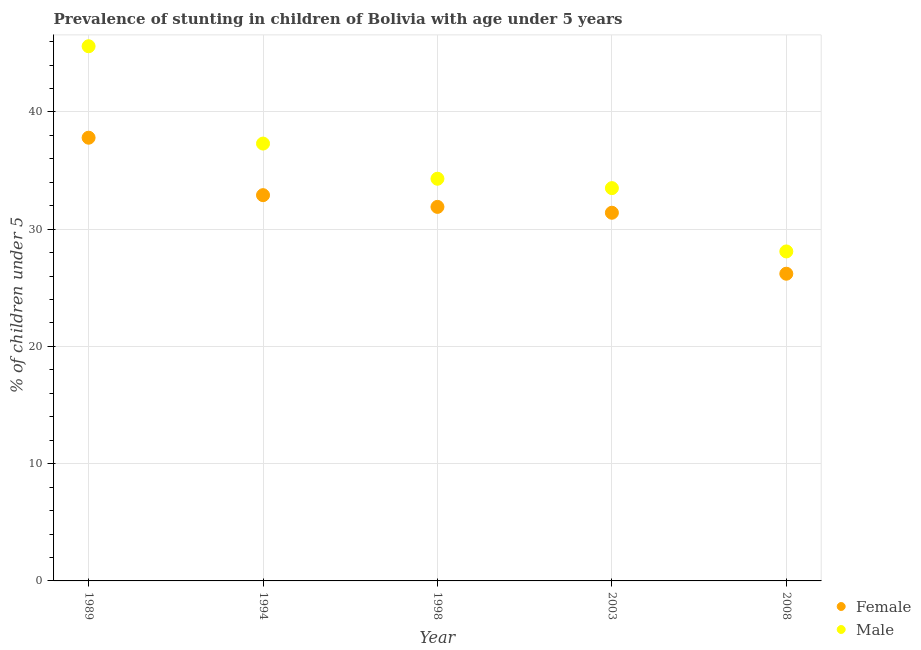What is the percentage of stunted male children in 1998?
Your response must be concise. 34.3. Across all years, what is the maximum percentage of stunted female children?
Provide a short and direct response. 37.8. Across all years, what is the minimum percentage of stunted female children?
Your answer should be very brief. 26.2. In which year was the percentage of stunted male children minimum?
Offer a terse response. 2008. What is the total percentage of stunted female children in the graph?
Provide a succinct answer. 160.2. What is the difference between the percentage of stunted male children in 1989 and that in 1998?
Ensure brevity in your answer.  11.3. What is the difference between the percentage of stunted male children in 1998 and the percentage of stunted female children in 2008?
Offer a terse response. 8.1. What is the average percentage of stunted female children per year?
Your response must be concise. 32.04. In the year 1998, what is the difference between the percentage of stunted male children and percentage of stunted female children?
Offer a very short reply. 2.4. What is the ratio of the percentage of stunted male children in 1994 to that in 2008?
Your response must be concise. 1.33. What is the difference between the highest and the second highest percentage of stunted male children?
Your response must be concise. 8.3. What is the difference between the highest and the lowest percentage of stunted female children?
Offer a very short reply. 11.6. In how many years, is the percentage of stunted male children greater than the average percentage of stunted male children taken over all years?
Provide a short and direct response. 2. Does the percentage of stunted female children monotonically increase over the years?
Your response must be concise. No. Is the percentage of stunted female children strictly greater than the percentage of stunted male children over the years?
Your response must be concise. No. Is the percentage of stunted male children strictly less than the percentage of stunted female children over the years?
Your answer should be very brief. No. What is the title of the graph?
Give a very brief answer. Prevalence of stunting in children of Bolivia with age under 5 years. What is the label or title of the X-axis?
Give a very brief answer. Year. What is the label or title of the Y-axis?
Ensure brevity in your answer.   % of children under 5. What is the  % of children under 5 in Female in 1989?
Keep it short and to the point. 37.8. What is the  % of children under 5 in Male in 1989?
Your answer should be very brief. 45.6. What is the  % of children under 5 in Female in 1994?
Give a very brief answer. 32.9. What is the  % of children under 5 in Male in 1994?
Your answer should be compact. 37.3. What is the  % of children under 5 of Female in 1998?
Your answer should be very brief. 31.9. What is the  % of children under 5 of Male in 1998?
Provide a short and direct response. 34.3. What is the  % of children under 5 in Female in 2003?
Provide a short and direct response. 31.4. What is the  % of children under 5 of Male in 2003?
Keep it short and to the point. 33.5. What is the  % of children under 5 of Female in 2008?
Give a very brief answer. 26.2. What is the  % of children under 5 in Male in 2008?
Your answer should be very brief. 28.1. Across all years, what is the maximum  % of children under 5 of Female?
Your response must be concise. 37.8. Across all years, what is the maximum  % of children under 5 in Male?
Ensure brevity in your answer.  45.6. Across all years, what is the minimum  % of children under 5 of Female?
Give a very brief answer. 26.2. Across all years, what is the minimum  % of children under 5 of Male?
Provide a short and direct response. 28.1. What is the total  % of children under 5 of Female in the graph?
Ensure brevity in your answer.  160.2. What is the total  % of children under 5 of Male in the graph?
Give a very brief answer. 178.8. What is the difference between the  % of children under 5 in Male in 1989 and that in 1994?
Offer a terse response. 8.3. What is the difference between the  % of children under 5 of Male in 1989 and that in 1998?
Offer a very short reply. 11.3. What is the difference between the  % of children under 5 of Female in 1989 and that in 2003?
Ensure brevity in your answer.  6.4. What is the difference between the  % of children under 5 in Male in 1989 and that in 2003?
Offer a terse response. 12.1. What is the difference between the  % of children under 5 of Female in 1989 and that in 2008?
Keep it short and to the point. 11.6. What is the difference between the  % of children under 5 of Female in 1994 and that in 1998?
Provide a succinct answer. 1. What is the difference between the  % of children under 5 of Male in 1994 and that in 2003?
Your response must be concise. 3.8. What is the difference between the  % of children under 5 of Female in 1994 and that in 2008?
Make the answer very short. 6.7. What is the difference between the  % of children under 5 of Female in 1998 and that in 2003?
Your response must be concise. 0.5. What is the difference between the  % of children under 5 in Male in 1998 and that in 2003?
Your response must be concise. 0.8. What is the difference between the  % of children under 5 of Male in 1998 and that in 2008?
Your answer should be compact. 6.2. What is the difference between the  % of children under 5 of Female in 2003 and that in 2008?
Make the answer very short. 5.2. What is the difference between the  % of children under 5 in Male in 2003 and that in 2008?
Provide a short and direct response. 5.4. What is the difference between the  % of children under 5 of Female in 1989 and the  % of children under 5 of Male in 1994?
Offer a terse response. 0.5. What is the difference between the  % of children under 5 in Female in 1989 and the  % of children under 5 in Male in 2003?
Keep it short and to the point. 4.3. What is the difference between the  % of children under 5 in Female in 1994 and the  % of children under 5 in Male in 2008?
Your response must be concise. 4.8. What is the difference between the  % of children under 5 in Female in 2003 and the  % of children under 5 in Male in 2008?
Provide a short and direct response. 3.3. What is the average  % of children under 5 in Female per year?
Your response must be concise. 32.04. What is the average  % of children under 5 of Male per year?
Provide a succinct answer. 35.76. In the year 1989, what is the difference between the  % of children under 5 of Female and  % of children under 5 of Male?
Provide a short and direct response. -7.8. In the year 1994, what is the difference between the  % of children under 5 in Female and  % of children under 5 in Male?
Offer a very short reply. -4.4. In the year 1998, what is the difference between the  % of children under 5 in Female and  % of children under 5 in Male?
Give a very brief answer. -2.4. What is the ratio of the  % of children under 5 of Female in 1989 to that in 1994?
Give a very brief answer. 1.15. What is the ratio of the  % of children under 5 in Male in 1989 to that in 1994?
Provide a succinct answer. 1.22. What is the ratio of the  % of children under 5 of Female in 1989 to that in 1998?
Provide a succinct answer. 1.19. What is the ratio of the  % of children under 5 in Male in 1989 to that in 1998?
Ensure brevity in your answer.  1.33. What is the ratio of the  % of children under 5 in Female in 1989 to that in 2003?
Your answer should be very brief. 1.2. What is the ratio of the  % of children under 5 in Male in 1989 to that in 2003?
Offer a terse response. 1.36. What is the ratio of the  % of children under 5 in Female in 1989 to that in 2008?
Give a very brief answer. 1.44. What is the ratio of the  % of children under 5 of Male in 1989 to that in 2008?
Your response must be concise. 1.62. What is the ratio of the  % of children under 5 in Female in 1994 to that in 1998?
Offer a very short reply. 1.03. What is the ratio of the  % of children under 5 of Male in 1994 to that in 1998?
Keep it short and to the point. 1.09. What is the ratio of the  % of children under 5 in Female in 1994 to that in 2003?
Keep it short and to the point. 1.05. What is the ratio of the  % of children under 5 in Male in 1994 to that in 2003?
Give a very brief answer. 1.11. What is the ratio of the  % of children under 5 in Female in 1994 to that in 2008?
Your answer should be very brief. 1.26. What is the ratio of the  % of children under 5 in Male in 1994 to that in 2008?
Your answer should be very brief. 1.33. What is the ratio of the  % of children under 5 of Female in 1998 to that in 2003?
Offer a very short reply. 1.02. What is the ratio of the  % of children under 5 in Male in 1998 to that in 2003?
Ensure brevity in your answer.  1.02. What is the ratio of the  % of children under 5 in Female in 1998 to that in 2008?
Offer a terse response. 1.22. What is the ratio of the  % of children under 5 in Male in 1998 to that in 2008?
Provide a succinct answer. 1.22. What is the ratio of the  % of children under 5 of Female in 2003 to that in 2008?
Make the answer very short. 1.2. What is the ratio of the  % of children under 5 of Male in 2003 to that in 2008?
Offer a terse response. 1.19. What is the difference between the highest and the lowest  % of children under 5 in Female?
Ensure brevity in your answer.  11.6. What is the difference between the highest and the lowest  % of children under 5 of Male?
Provide a short and direct response. 17.5. 